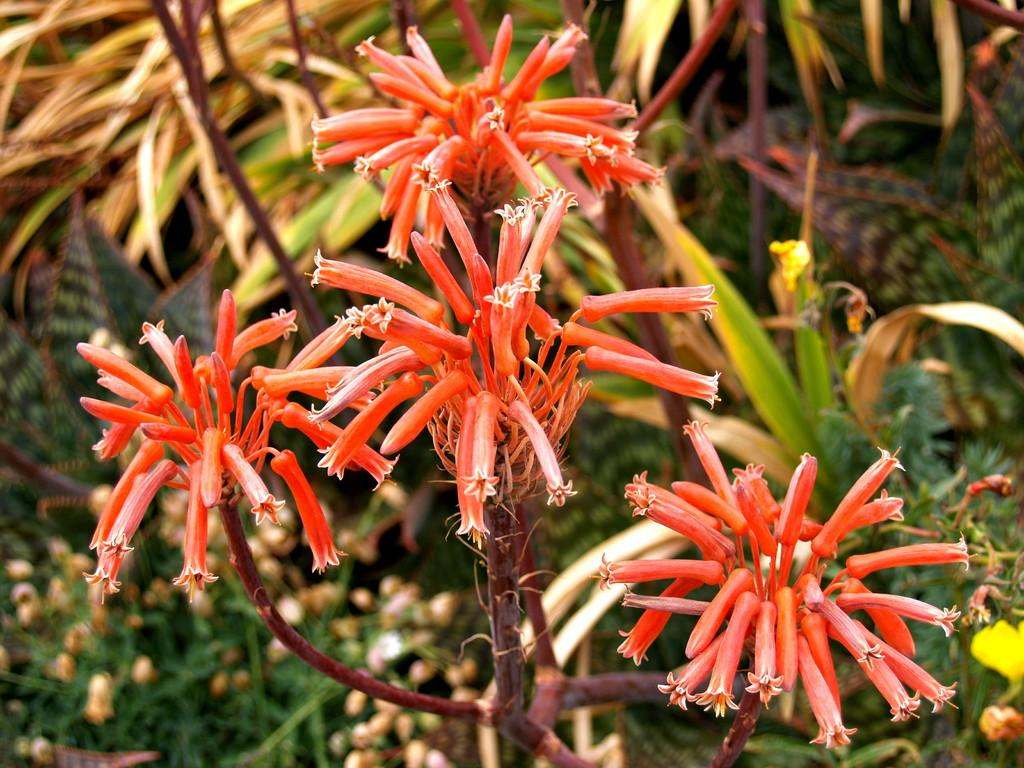What type of living organisms can be seen in the image? There is a group of flowers and plants in the image. Can you describe the flowers in the image? The provided facts do not specify the type or color of the flowers, so we cannot provide a detailed description. What is the primary subject of the image? The primary subject of the image is a group of flowers. What type of interest does the person in the image have in society? There is no person present in the image, so we cannot determine their interest in society. 